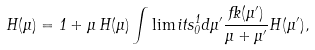<formula> <loc_0><loc_0><loc_500><loc_500>H ( \mu ) = 1 + \mu \, H ( \mu ) \int \lim i t s _ { 0 } ^ { 1 } d \mu ^ { \prime } \frac { \Psi ( \mu ^ { \prime } ) } { \mu + \mu ^ { \prime } } H ( \mu ^ { \prime } ) ,</formula> 